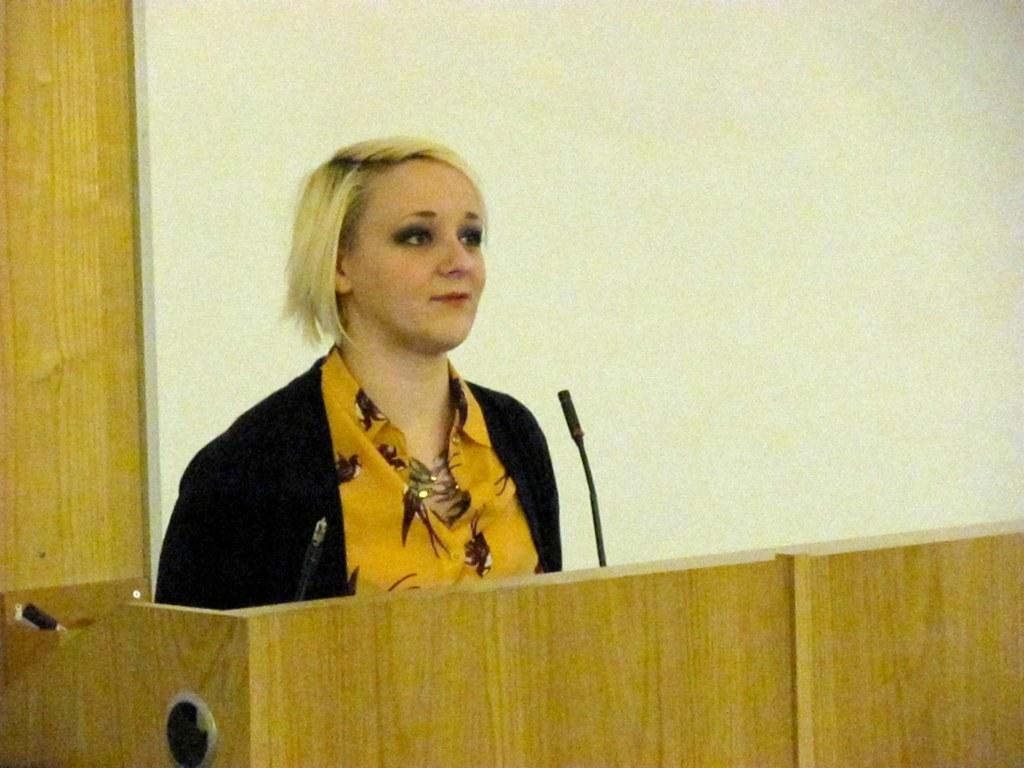Could you give a brief overview of what you see in this image? In the image we can see there is a woman standing near the podium and there is a mic in front of her. Behind there is a wall which is in white colour. 